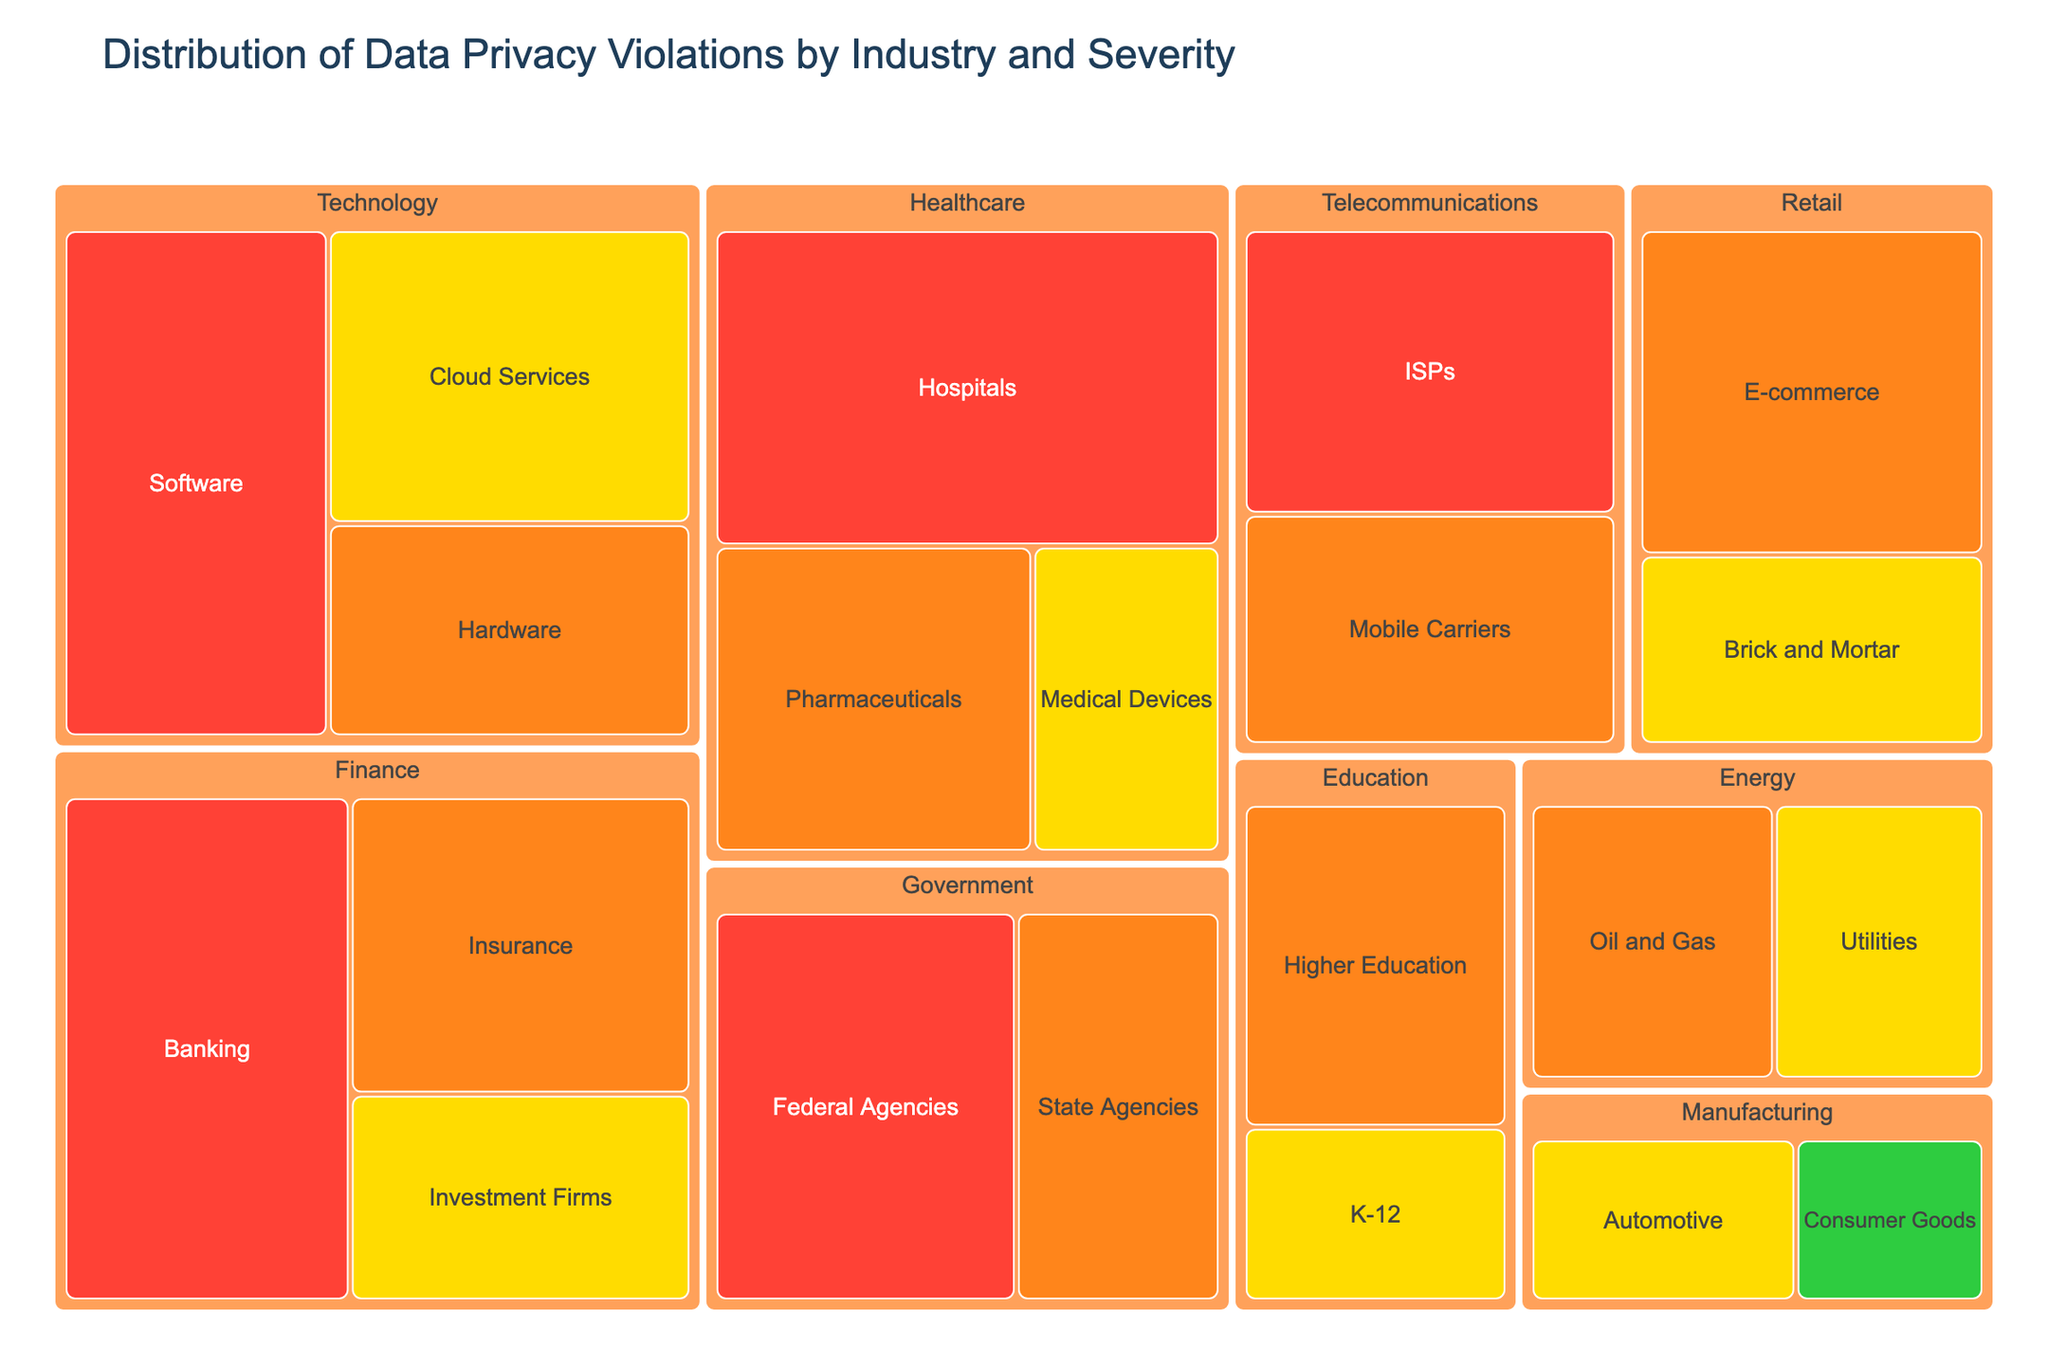What is the title of the treemap? The title is located at the top of the treemap, written in a larger and distinct font. It provides a summary of what the visualization represents.
Answer: Distribution of Data Privacy Violations by Industry and Severity Which industry has the highest number of critical violations? Locate the segments colored according to the severity level 'Critical', identified by the color mapped to 'Critical' in the treemap. The'Healthcare' segment is the largest within these critical violations.
Answer: Healthcare How many violations are there in the Education sector in total? Identify the 'Education' segment and sum up the violations across both 'Higher Education' and 'K-12', which are the sub-sectors depicted within it. There are 52 violations in Higher Education + 28 in K-12 = 80 total violations.
Answer: 80 Which sector in the Finance industry has the most data privacy violations? Focus on the 'Finance' industry section and compare its sub-segments: 'Banking', 'Insurance', 'Investment Firms'. 'Banking' has the largest segment representing 84 violations.
Answer: Banking What is the range of violations based on severity across all industries? Identify the smallest and largest violation numbers associated with each severity level. The lowest number listed is 22 (Low), and the highest is 92 (Critical). Calculate the range as 92 - 22 = 70.
Answer: 70 Compare the total violations between the Government and Retail industries. Which has more? Sum the violations in 'Government' (Federal Agencies + State Agencies = 71 + 48 = 119) and 'Retail' (E-commerce + Brick and Mortar = 67 + 39 = 106). Government has more violations.
Answer: Government Which severity level is least represented in the Treemap? Count the occurrences of each severity level ('Critical', 'High', 'Medium', 'Low'), and identify the level with the fewest segments. 'Low' has the only one segment, making it the least represented.
Answer: Low Which industry has the widest variety of severity levels in its violations? Examine each industry’s sections and count how many different severity levels ('Critical', 'High', 'Medium', 'Low') are represented. 'Healthcare' has 'Critical', 'High', and 'Medium' severity levels, representing the most diverse range.
Answer: Healthcare What is the difference in the number of violations between the Telecommunications sector's 'ISPs' and 'Mobile Carriers'? Compare the violations in both 'ISPs' (63) and 'Mobile Carriers' (51) within the Telecommunications industry. The difference is 63 - 51 = 12.
Answer: 12 What color is used to represent 'Medium' severity violations? The treemap utilizes a specific color mapping for severity levels. The segment color for 'Medium' violations is a shade of yellow as indicated in the color legend.
Answer: Yellow 